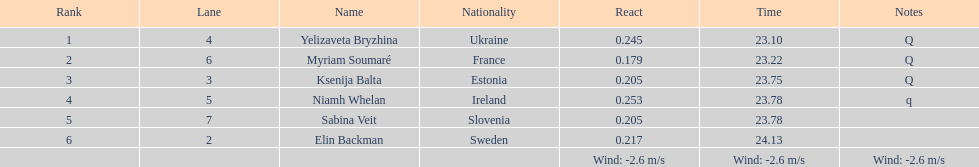Identify the sportswoman who finished first in heat 1 of the women's 200 meters. Yelizaveta Bryzhina. 